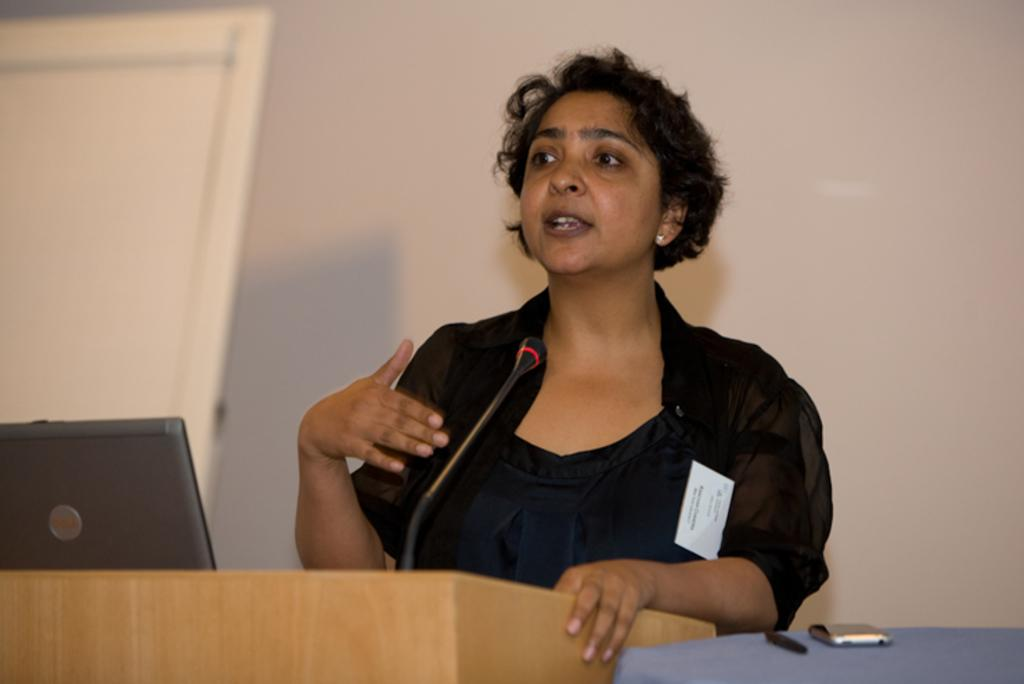Who is the main subject in the image? There is a woman in the image. What is the woman doing in the image? The woman is standing in front of a microphone and talking. What objects can be seen near the woman? There is a podium, a laptop, a pen, and a mobile phone in the image. What can be seen in the background of the image? There is a wall and a door in the background of the image. How many letters can be seen on the mobile phone in the image? There are no letters visible on the mobile phone in the image. Can you describe the woman's kick in the image? There is no kick performed by the woman in the image. 